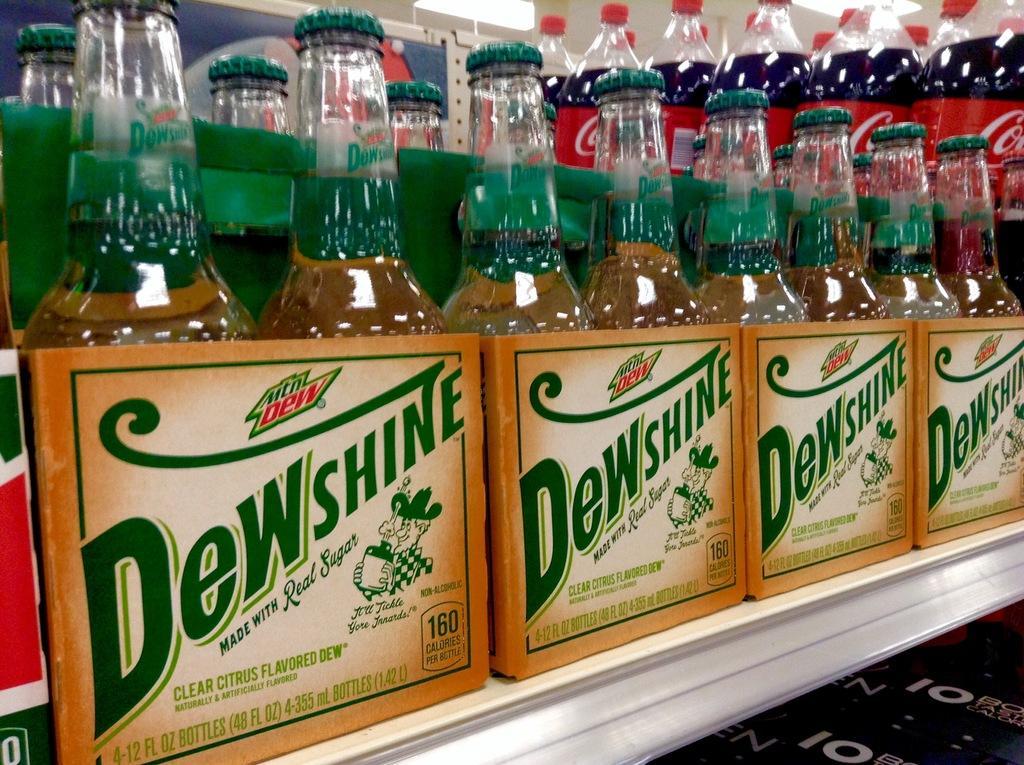Describe this image in one or two sentences. In this picture there are many bottles in box. There is a light. 